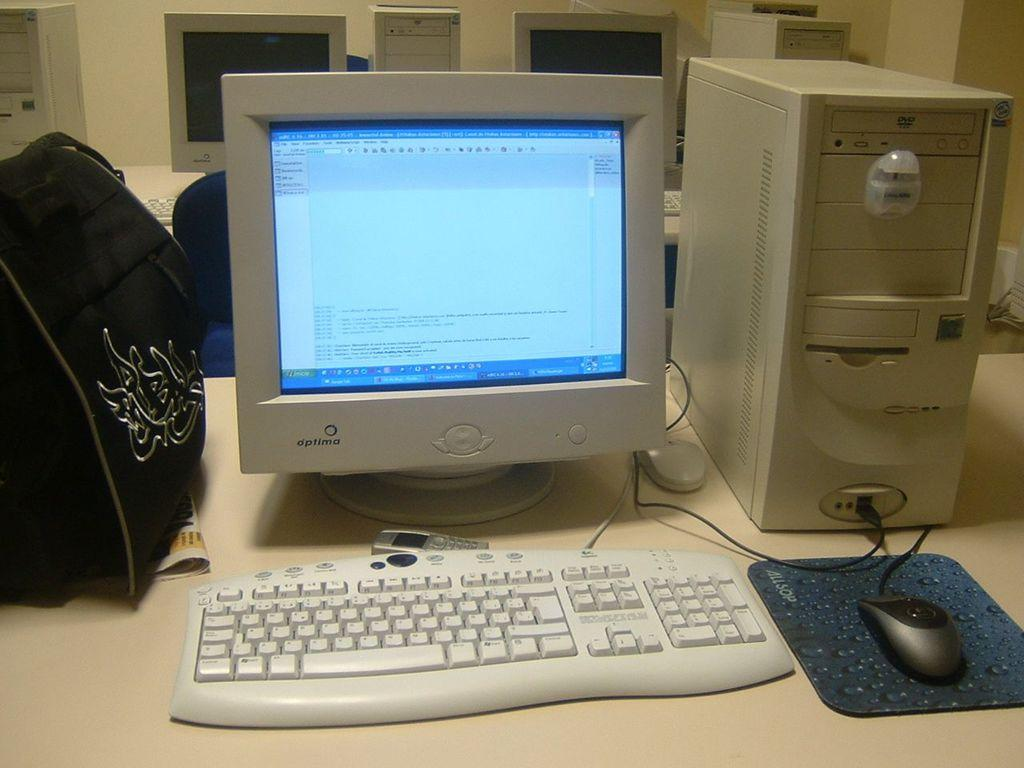<image>
Summarize the visual content of the image. The make of the mouse mat shown is Allsop. 